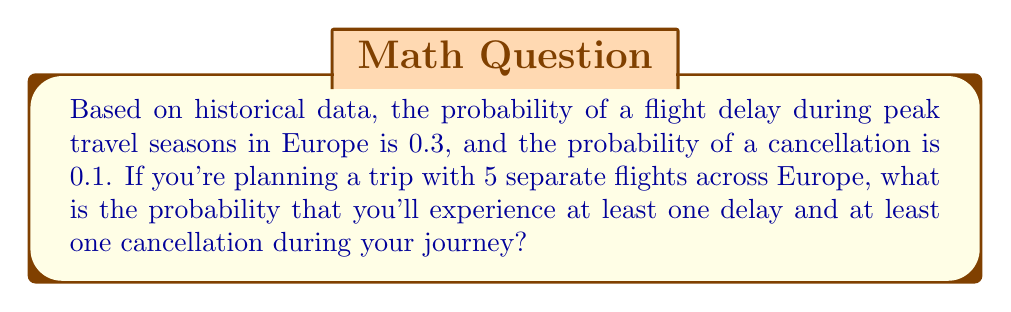Teach me how to tackle this problem. Let's approach this step-by-step:

1) First, let's define our events:
   D: experiencing at least one delay
   C: experiencing at least one cancellation

2) We need to find P(D ∩ C), the probability of both events occurring.

3) It's easier to calculate the complement of this probability:
   P(D ∩ C) = 1 - P(D' ∪ C')
   where D' is the event of no delays and C' is the event of no cancellations.

4) For no delays in 5 flights:
   P(D') = $(0.7)^5$ (as 0.7 is the probability of no delay for each flight)

5) For no cancellations in 5 flights:
   P(C') = $(0.9)^5$ (as 0.9 is the probability of no cancellation for each flight)

6) Using the addition rule of probability:
   P(D' ∪ C') = P(D') + P(C') - P(D' ∩ C')
               = P(D') + P(C') - P(D')P(C')  (as the events are independent)
               = $(0.7)^5 + (0.9)^5 - (0.7)^5(0.9)^5$

7) Therefore:
   P(D ∩ C) = 1 - P(D' ∪ C')
             = 1 - [$(0.7)^5 + (0.9)^5 - (0.7)^5(0.9)^5$]
             = 1 - [0.16807 + 0.59049 - 0.09923]
             = 1 - 0.65933
             = 0.34067
Answer: 0.34067 